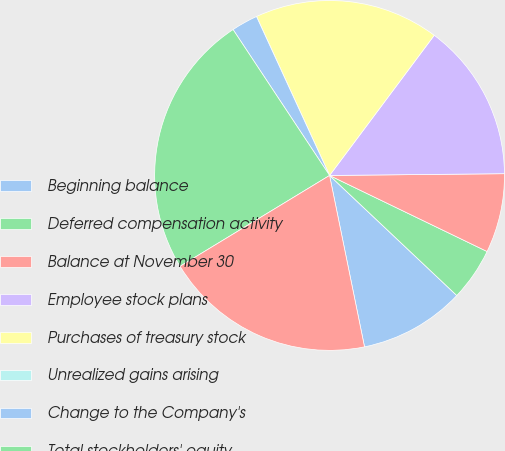Convert chart. <chart><loc_0><loc_0><loc_500><loc_500><pie_chart><fcel>Beginning balance<fcel>Deferred compensation activity<fcel>Balance at November 30<fcel>Employee stock plans<fcel>Purchases of treasury stock<fcel>Unrealized gains arising<fcel>Change to the Company's<fcel>Total stockholders' equity<fcel>Comprehensive income<nl><fcel>9.76%<fcel>4.88%<fcel>7.32%<fcel>14.63%<fcel>17.07%<fcel>0.0%<fcel>2.44%<fcel>24.39%<fcel>19.51%<nl></chart> 